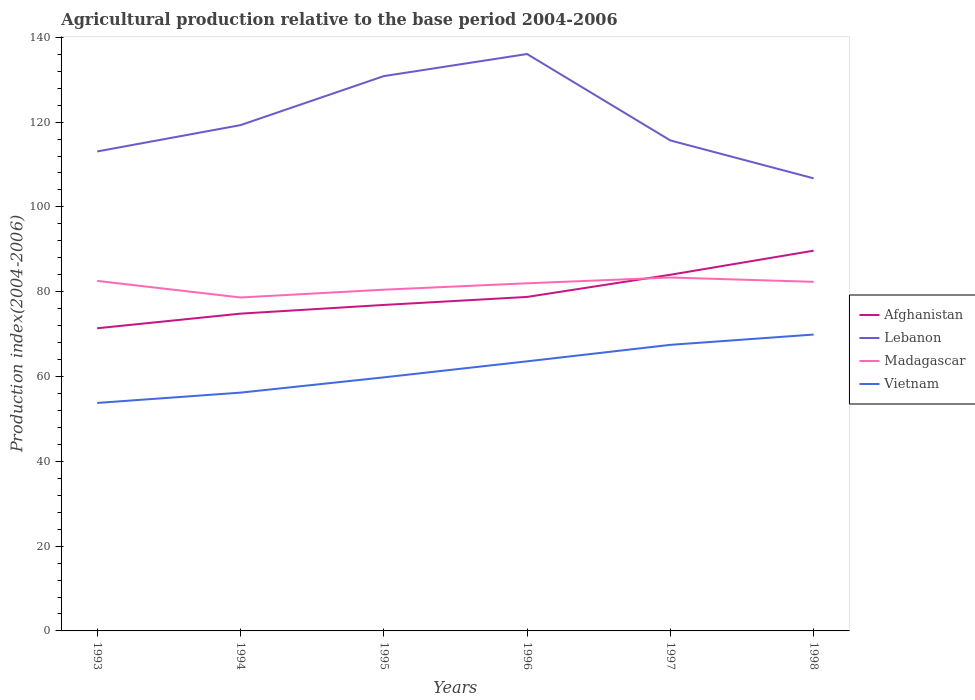How many different coloured lines are there?
Provide a succinct answer. 4. Is the number of lines equal to the number of legend labels?
Give a very brief answer. Yes. Across all years, what is the maximum agricultural production index in Afghanistan?
Provide a short and direct response. 71.38. What is the total agricultural production index in Madagascar in the graph?
Provide a short and direct response. -0.34. What is the difference between the highest and the second highest agricultural production index in Vietnam?
Provide a succinct answer. 16.13. What is the difference between the highest and the lowest agricultural production index in Lebanon?
Provide a succinct answer. 2. Is the agricultural production index in Afghanistan strictly greater than the agricultural production index in Vietnam over the years?
Your response must be concise. No. How many lines are there?
Make the answer very short. 4. Are the values on the major ticks of Y-axis written in scientific E-notation?
Provide a short and direct response. No. How are the legend labels stacked?
Provide a short and direct response. Vertical. What is the title of the graph?
Offer a terse response. Agricultural production relative to the base period 2004-2006. What is the label or title of the Y-axis?
Your response must be concise. Production index(2004-2006). What is the Production index(2004-2006) of Afghanistan in 1993?
Ensure brevity in your answer.  71.38. What is the Production index(2004-2006) in Lebanon in 1993?
Keep it short and to the point. 113.08. What is the Production index(2004-2006) of Madagascar in 1993?
Keep it short and to the point. 82.55. What is the Production index(2004-2006) in Vietnam in 1993?
Offer a terse response. 53.77. What is the Production index(2004-2006) of Afghanistan in 1994?
Make the answer very short. 74.83. What is the Production index(2004-2006) in Lebanon in 1994?
Ensure brevity in your answer.  119.29. What is the Production index(2004-2006) of Madagascar in 1994?
Your response must be concise. 78.64. What is the Production index(2004-2006) in Vietnam in 1994?
Ensure brevity in your answer.  56.2. What is the Production index(2004-2006) of Afghanistan in 1995?
Your response must be concise. 76.88. What is the Production index(2004-2006) in Lebanon in 1995?
Provide a short and direct response. 130.85. What is the Production index(2004-2006) in Madagascar in 1995?
Give a very brief answer. 80.48. What is the Production index(2004-2006) of Vietnam in 1995?
Keep it short and to the point. 59.8. What is the Production index(2004-2006) of Afghanistan in 1996?
Keep it short and to the point. 78.77. What is the Production index(2004-2006) in Lebanon in 1996?
Offer a very short reply. 136.06. What is the Production index(2004-2006) of Madagascar in 1996?
Make the answer very short. 81.99. What is the Production index(2004-2006) of Vietnam in 1996?
Offer a terse response. 63.58. What is the Production index(2004-2006) of Afghanistan in 1997?
Keep it short and to the point. 84. What is the Production index(2004-2006) in Lebanon in 1997?
Make the answer very short. 115.68. What is the Production index(2004-2006) in Madagascar in 1997?
Your response must be concise. 83.35. What is the Production index(2004-2006) of Vietnam in 1997?
Offer a very short reply. 67.47. What is the Production index(2004-2006) of Afghanistan in 1998?
Ensure brevity in your answer.  89.68. What is the Production index(2004-2006) in Lebanon in 1998?
Your response must be concise. 106.74. What is the Production index(2004-2006) in Madagascar in 1998?
Provide a succinct answer. 82.33. What is the Production index(2004-2006) in Vietnam in 1998?
Keep it short and to the point. 69.9. Across all years, what is the maximum Production index(2004-2006) of Afghanistan?
Make the answer very short. 89.68. Across all years, what is the maximum Production index(2004-2006) of Lebanon?
Offer a very short reply. 136.06. Across all years, what is the maximum Production index(2004-2006) of Madagascar?
Provide a succinct answer. 83.35. Across all years, what is the maximum Production index(2004-2006) of Vietnam?
Provide a succinct answer. 69.9. Across all years, what is the minimum Production index(2004-2006) of Afghanistan?
Keep it short and to the point. 71.38. Across all years, what is the minimum Production index(2004-2006) in Lebanon?
Provide a succinct answer. 106.74. Across all years, what is the minimum Production index(2004-2006) in Madagascar?
Offer a very short reply. 78.64. Across all years, what is the minimum Production index(2004-2006) of Vietnam?
Give a very brief answer. 53.77. What is the total Production index(2004-2006) in Afghanistan in the graph?
Your answer should be very brief. 475.54. What is the total Production index(2004-2006) in Lebanon in the graph?
Provide a succinct answer. 721.7. What is the total Production index(2004-2006) in Madagascar in the graph?
Keep it short and to the point. 489.34. What is the total Production index(2004-2006) in Vietnam in the graph?
Offer a terse response. 370.72. What is the difference between the Production index(2004-2006) in Afghanistan in 1993 and that in 1994?
Provide a succinct answer. -3.45. What is the difference between the Production index(2004-2006) in Lebanon in 1993 and that in 1994?
Ensure brevity in your answer.  -6.21. What is the difference between the Production index(2004-2006) of Madagascar in 1993 and that in 1994?
Make the answer very short. 3.91. What is the difference between the Production index(2004-2006) of Vietnam in 1993 and that in 1994?
Your answer should be compact. -2.43. What is the difference between the Production index(2004-2006) of Lebanon in 1993 and that in 1995?
Your answer should be very brief. -17.77. What is the difference between the Production index(2004-2006) of Madagascar in 1993 and that in 1995?
Offer a very short reply. 2.07. What is the difference between the Production index(2004-2006) in Vietnam in 1993 and that in 1995?
Provide a short and direct response. -6.03. What is the difference between the Production index(2004-2006) in Afghanistan in 1993 and that in 1996?
Your answer should be compact. -7.39. What is the difference between the Production index(2004-2006) in Lebanon in 1993 and that in 1996?
Provide a succinct answer. -22.98. What is the difference between the Production index(2004-2006) in Madagascar in 1993 and that in 1996?
Provide a short and direct response. 0.56. What is the difference between the Production index(2004-2006) of Vietnam in 1993 and that in 1996?
Ensure brevity in your answer.  -9.81. What is the difference between the Production index(2004-2006) of Afghanistan in 1993 and that in 1997?
Your answer should be compact. -12.62. What is the difference between the Production index(2004-2006) of Lebanon in 1993 and that in 1997?
Provide a short and direct response. -2.6. What is the difference between the Production index(2004-2006) in Madagascar in 1993 and that in 1997?
Your response must be concise. -0.8. What is the difference between the Production index(2004-2006) in Vietnam in 1993 and that in 1997?
Make the answer very short. -13.7. What is the difference between the Production index(2004-2006) of Afghanistan in 1993 and that in 1998?
Your answer should be very brief. -18.3. What is the difference between the Production index(2004-2006) of Lebanon in 1993 and that in 1998?
Provide a succinct answer. 6.34. What is the difference between the Production index(2004-2006) in Madagascar in 1993 and that in 1998?
Your answer should be very brief. 0.22. What is the difference between the Production index(2004-2006) in Vietnam in 1993 and that in 1998?
Provide a succinct answer. -16.13. What is the difference between the Production index(2004-2006) in Afghanistan in 1994 and that in 1995?
Offer a very short reply. -2.05. What is the difference between the Production index(2004-2006) in Lebanon in 1994 and that in 1995?
Your answer should be compact. -11.56. What is the difference between the Production index(2004-2006) in Madagascar in 1994 and that in 1995?
Your answer should be very brief. -1.84. What is the difference between the Production index(2004-2006) in Vietnam in 1994 and that in 1995?
Give a very brief answer. -3.6. What is the difference between the Production index(2004-2006) in Afghanistan in 1994 and that in 1996?
Your answer should be very brief. -3.94. What is the difference between the Production index(2004-2006) in Lebanon in 1994 and that in 1996?
Offer a terse response. -16.77. What is the difference between the Production index(2004-2006) in Madagascar in 1994 and that in 1996?
Keep it short and to the point. -3.35. What is the difference between the Production index(2004-2006) of Vietnam in 1994 and that in 1996?
Offer a very short reply. -7.38. What is the difference between the Production index(2004-2006) of Afghanistan in 1994 and that in 1997?
Provide a succinct answer. -9.17. What is the difference between the Production index(2004-2006) of Lebanon in 1994 and that in 1997?
Provide a short and direct response. 3.61. What is the difference between the Production index(2004-2006) of Madagascar in 1994 and that in 1997?
Offer a very short reply. -4.71. What is the difference between the Production index(2004-2006) of Vietnam in 1994 and that in 1997?
Your response must be concise. -11.27. What is the difference between the Production index(2004-2006) in Afghanistan in 1994 and that in 1998?
Offer a terse response. -14.85. What is the difference between the Production index(2004-2006) of Lebanon in 1994 and that in 1998?
Ensure brevity in your answer.  12.55. What is the difference between the Production index(2004-2006) in Madagascar in 1994 and that in 1998?
Keep it short and to the point. -3.69. What is the difference between the Production index(2004-2006) of Vietnam in 1994 and that in 1998?
Offer a terse response. -13.7. What is the difference between the Production index(2004-2006) of Afghanistan in 1995 and that in 1996?
Provide a succinct answer. -1.89. What is the difference between the Production index(2004-2006) in Lebanon in 1995 and that in 1996?
Offer a terse response. -5.21. What is the difference between the Production index(2004-2006) in Madagascar in 1995 and that in 1996?
Keep it short and to the point. -1.51. What is the difference between the Production index(2004-2006) of Vietnam in 1995 and that in 1996?
Make the answer very short. -3.78. What is the difference between the Production index(2004-2006) of Afghanistan in 1995 and that in 1997?
Ensure brevity in your answer.  -7.12. What is the difference between the Production index(2004-2006) of Lebanon in 1995 and that in 1997?
Offer a very short reply. 15.17. What is the difference between the Production index(2004-2006) of Madagascar in 1995 and that in 1997?
Provide a short and direct response. -2.87. What is the difference between the Production index(2004-2006) in Vietnam in 1995 and that in 1997?
Your response must be concise. -7.67. What is the difference between the Production index(2004-2006) in Lebanon in 1995 and that in 1998?
Offer a very short reply. 24.11. What is the difference between the Production index(2004-2006) in Madagascar in 1995 and that in 1998?
Offer a terse response. -1.85. What is the difference between the Production index(2004-2006) of Afghanistan in 1996 and that in 1997?
Keep it short and to the point. -5.23. What is the difference between the Production index(2004-2006) in Lebanon in 1996 and that in 1997?
Keep it short and to the point. 20.38. What is the difference between the Production index(2004-2006) in Madagascar in 1996 and that in 1997?
Ensure brevity in your answer.  -1.36. What is the difference between the Production index(2004-2006) of Vietnam in 1996 and that in 1997?
Give a very brief answer. -3.89. What is the difference between the Production index(2004-2006) of Afghanistan in 1996 and that in 1998?
Provide a succinct answer. -10.91. What is the difference between the Production index(2004-2006) in Lebanon in 1996 and that in 1998?
Offer a terse response. 29.32. What is the difference between the Production index(2004-2006) of Madagascar in 1996 and that in 1998?
Make the answer very short. -0.34. What is the difference between the Production index(2004-2006) of Vietnam in 1996 and that in 1998?
Offer a terse response. -6.32. What is the difference between the Production index(2004-2006) in Afghanistan in 1997 and that in 1998?
Make the answer very short. -5.68. What is the difference between the Production index(2004-2006) in Lebanon in 1997 and that in 1998?
Your answer should be compact. 8.94. What is the difference between the Production index(2004-2006) in Vietnam in 1997 and that in 1998?
Your response must be concise. -2.43. What is the difference between the Production index(2004-2006) in Afghanistan in 1993 and the Production index(2004-2006) in Lebanon in 1994?
Keep it short and to the point. -47.91. What is the difference between the Production index(2004-2006) in Afghanistan in 1993 and the Production index(2004-2006) in Madagascar in 1994?
Offer a very short reply. -7.26. What is the difference between the Production index(2004-2006) in Afghanistan in 1993 and the Production index(2004-2006) in Vietnam in 1994?
Provide a short and direct response. 15.18. What is the difference between the Production index(2004-2006) in Lebanon in 1993 and the Production index(2004-2006) in Madagascar in 1994?
Your answer should be very brief. 34.44. What is the difference between the Production index(2004-2006) in Lebanon in 1993 and the Production index(2004-2006) in Vietnam in 1994?
Offer a very short reply. 56.88. What is the difference between the Production index(2004-2006) of Madagascar in 1993 and the Production index(2004-2006) of Vietnam in 1994?
Offer a terse response. 26.35. What is the difference between the Production index(2004-2006) of Afghanistan in 1993 and the Production index(2004-2006) of Lebanon in 1995?
Your answer should be very brief. -59.47. What is the difference between the Production index(2004-2006) in Afghanistan in 1993 and the Production index(2004-2006) in Vietnam in 1995?
Provide a short and direct response. 11.58. What is the difference between the Production index(2004-2006) of Lebanon in 1993 and the Production index(2004-2006) of Madagascar in 1995?
Offer a very short reply. 32.6. What is the difference between the Production index(2004-2006) of Lebanon in 1993 and the Production index(2004-2006) of Vietnam in 1995?
Provide a short and direct response. 53.28. What is the difference between the Production index(2004-2006) of Madagascar in 1993 and the Production index(2004-2006) of Vietnam in 1995?
Provide a short and direct response. 22.75. What is the difference between the Production index(2004-2006) of Afghanistan in 1993 and the Production index(2004-2006) of Lebanon in 1996?
Offer a terse response. -64.68. What is the difference between the Production index(2004-2006) in Afghanistan in 1993 and the Production index(2004-2006) in Madagascar in 1996?
Your answer should be compact. -10.61. What is the difference between the Production index(2004-2006) in Lebanon in 1993 and the Production index(2004-2006) in Madagascar in 1996?
Give a very brief answer. 31.09. What is the difference between the Production index(2004-2006) of Lebanon in 1993 and the Production index(2004-2006) of Vietnam in 1996?
Make the answer very short. 49.5. What is the difference between the Production index(2004-2006) of Madagascar in 1993 and the Production index(2004-2006) of Vietnam in 1996?
Offer a terse response. 18.97. What is the difference between the Production index(2004-2006) in Afghanistan in 1993 and the Production index(2004-2006) in Lebanon in 1997?
Make the answer very short. -44.3. What is the difference between the Production index(2004-2006) in Afghanistan in 1993 and the Production index(2004-2006) in Madagascar in 1997?
Make the answer very short. -11.97. What is the difference between the Production index(2004-2006) of Afghanistan in 1993 and the Production index(2004-2006) of Vietnam in 1997?
Your response must be concise. 3.91. What is the difference between the Production index(2004-2006) in Lebanon in 1993 and the Production index(2004-2006) in Madagascar in 1997?
Make the answer very short. 29.73. What is the difference between the Production index(2004-2006) in Lebanon in 1993 and the Production index(2004-2006) in Vietnam in 1997?
Your response must be concise. 45.61. What is the difference between the Production index(2004-2006) in Madagascar in 1993 and the Production index(2004-2006) in Vietnam in 1997?
Provide a short and direct response. 15.08. What is the difference between the Production index(2004-2006) in Afghanistan in 1993 and the Production index(2004-2006) in Lebanon in 1998?
Ensure brevity in your answer.  -35.36. What is the difference between the Production index(2004-2006) in Afghanistan in 1993 and the Production index(2004-2006) in Madagascar in 1998?
Offer a terse response. -10.95. What is the difference between the Production index(2004-2006) of Afghanistan in 1993 and the Production index(2004-2006) of Vietnam in 1998?
Provide a succinct answer. 1.48. What is the difference between the Production index(2004-2006) in Lebanon in 1993 and the Production index(2004-2006) in Madagascar in 1998?
Give a very brief answer. 30.75. What is the difference between the Production index(2004-2006) of Lebanon in 1993 and the Production index(2004-2006) of Vietnam in 1998?
Ensure brevity in your answer.  43.18. What is the difference between the Production index(2004-2006) in Madagascar in 1993 and the Production index(2004-2006) in Vietnam in 1998?
Your response must be concise. 12.65. What is the difference between the Production index(2004-2006) of Afghanistan in 1994 and the Production index(2004-2006) of Lebanon in 1995?
Give a very brief answer. -56.02. What is the difference between the Production index(2004-2006) of Afghanistan in 1994 and the Production index(2004-2006) of Madagascar in 1995?
Offer a terse response. -5.65. What is the difference between the Production index(2004-2006) in Afghanistan in 1994 and the Production index(2004-2006) in Vietnam in 1995?
Keep it short and to the point. 15.03. What is the difference between the Production index(2004-2006) of Lebanon in 1994 and the Production index(2004-2006) of Madagascar in 1995?
Provide a succinct answer. 38.81. What is the difference between the Production index(2004-2006) in Lebanon in 1994 and the Production index(2004-2006) in Vietnam in 1995?
Provide a succinct answer. 59.49. What is the difference between the Production index(2004-2006) of Madagascar in 1994 and the Production index(2004-2006) of Vietnam in 1995?
Offer a very short reply. 18.84. What is the difference between the Production index(2004-2006) in Afghanistan in 1994 and the Production index(2004-2006) in Lebanon in 1996?
Provide a succinct answer. -61.23. What is the difference between the Production index(2004-2006) of Afghanistan in 1994 and the Production index(2004-2006) of Madagascar in 1996?
Provide a succinct answer. -7.16. What is the difference between the Production index(2004-2006) of Afghanistan in 1994 and the Production index(2004-2006) of Vietnam in 1996?
Ensure brevity in your answer.  11.25. What is the difference between the Production index(2004-2006) of Lebanon in 1994 and the Production index(2004-2006) of Madagascar in 1996?
Provide a short and direct response. 37.3. What is the difference between the Production index(2004-2006) of Lebanon in 1994 and the Production index(2004-2006) of Vietnam in 1996?
Offer a terse response. 55.71. What is the difference between the Production index(2004-2006) in Madagascar in 1994 and the Production index(2004-2006) in Vietnam in 1996?
Offer a very short reply. 15.06. What is the difference between the Production index(2004-2006) in Afghanistan in 1994 and the Production index(2004-2006) in Lebanon in 1997?
Make the answer very short. -40.85. What is the difference between the Production index(2004-2006) of Afghanistan in 1994 and the Production index(2004-2006) of Madagascar in 1997?
Give a very brief answer. -8.52. What is the difference between the Production index(2004-2006) in Afghanistan in 1994 and the Production index(2004-2006) in Vietnam in 1997?
Provide a short and direct response. 7.36. What is the difference between the Production index(2004-2006) in Lebanon in 1994 and the Production index(2004-2006) in Madagascar in 1997?
Offer a terse response. 35.94. What is the difference between the Production index(2004-2006) in Lebanon in 1994 and the Production index(2004-2006) in Vietnam in 1997?
Give a very brief answer. 51.82. What is the difference between the Production index(2004-2006) in Madagascar in 1994 and the Production index(2004-2006) in Vietnam in 1997?
Offer a very short reply. 11.17. What is the difference between the Production index(2004-2006) in Afghanistan in 1994 and the Production index(2004-2006) in Lebanon in 1998?
Provide a short and direct response. -31.91. What is the difference between the Production index(2004-2006) in Afghanistan in 1994 and the Production index(2004-2006) in Vietnam in 1998?
Offer a terse response. 4.93. What is the difference between the Production index(2004-2006) of Lebanon in 1994 and the Production index(2004-2006) of Madagascar in 1998?
Provide a succinct answer. 36.96. What is the difference between the Production index(2004-2006) of Lebanon in 1994 and the Production index(2004-2006) of Vietnam in 1998?
Offer a very short reply. 49.39. What is the difference between the Production index(2004-2006) of Madagascar in 1994 and the Production index(2004-2006) of Vietnam in 1998?
Offer a very short reply. 8.74. What is the difference between the Production index(2004-2006) of Afghanistan in 1995 and the Production index(2004-2006) of Lebanon in 1996?
Give a very brief answer. -59.18. What is the difference between the Production index(2004-2006) in Afghanistan in 1995 and the Production index(2004-2006) in Madagascar in 1996?
Give a very brief answer. -5.11. What is the difference between the Production index(2004-2006) in Lebanon in 1995 and the Production index(2004-2006) in Madagascar in 1996?
Make the answer very short. 48.86. What is the difference between the Production index(2004-2006) in Lebanon in 1995 and the Production index(2004-2006) in Vietnam in 1996?
Your answer should be compact. 67.27. What is the difference between the Production index(2004-2006) of Madagascar in 1995 and the Production index(2004-2006) of Vietnam in 1996?
Ensure brevity in your answer.  16.9. What is the difference between the Production index(2004-2006) of Afghanistan in 1995 and the Production index(2004-2006) of Lebanon in 1997?
Offer a terse response. -38.8. What is the difference between the Production index(2004-2006) of Afghanistan in 1995 and the Production index(2004-2006) of Madagascar in 1997?
Make the answer very short. -6.47. What is the difference between the Production index(2004-2006) in Afghanistan in 1995 and the Production index(2004-2006) in Vietnam in 1997?
Provide a short and direct response. 9.41. What is the difference between the Production index(2004-2006) in Lebanon in 1995 and the Production index(2004-2006) in Madagascar in 1997?
Give a very brief answer. 47.5. What is the difference between the Production index(2004-2006) in Lebanon in 1995 and the Production index(2004-2006) in Vietnam in 1997?
Offer a terse response. 63.38. What is the difference between the Production index(2004-2006) of Madagascar in 1995 and the Production index(2004-2006) of Vietnam in 1997?
Give a very brief answer. 13.01. What is the difference between the Production index(2004-2006) in Afghanistan in 1995 and the Production index(2004-2006) in Lebanon in 1998?
Provide a short and direct response. -29.86. What is the difference between the Production index(2004-2006) of Afghanistan in 1995 and the Production index(2004-2006) of Madagascar in 1998?
Give a very brief answer. -5.45. What is the difference between the Production index(2004-2006) of Afghanistan in 1995 and the Production index(2004-2006) of Vietnam in 1998?
Give a very brief answer. 6.98. What is the difference between the Production index(2004-2006) of Lebanon in 1995 and the Production index(2004-2006) of Madagascar in 1998?
Offer a terse response. 48.52. What is the difference between the Production index(2004-2006) of Lebanon in 1995 and the Production index(2004-2006) of Vietnam in 1998?
Your response must be concise. 60.95. What is the difference between the Production index(2004-2006) of Madagascar in 1995 and the Production index(2004-2006) of Vietnam in 1998?
Your response must be concise. 10.58. What is the difference between the Production index(2004-2006) in Afghanistan in 1996 and the Production index(2004-2006) in Lebanon in 1997?
Offer a terse response. -36.91. What is the difference between the Production index(2004-2006) in Afghanistan in 1996 and the Production index(2004-2006) in Madagascar in 1997?
Your response must be concise. -4.58. What is the difference between the Production index(2004-2006) in Afghanistan in 1996 and the Production index(2004-2006) in Vietnam in 1997?
Give a very brief answer. 11.3. What is the difference between the Production index(2004-2006) of Lebanon in 1996 and the Production index(2004-2006) of Madagascar in 1997?
Keep it short and to the point. 52.71. What is the difference between the Production index(2004-2006) of Lebanon in 1996 and the Production index(2004-2006) of Vietnam in 1997?
Provide a short and direct response. 68.59. What is the difference between the Production index(2004-2006) in Madagascar in 1996 and the Production index(2004-2006) in Vietnam in 1997?
Provide a succinct answer. 14.52. What is the difference between the Production index(2004-2006) in Afghanistan in 1996 and the Production index(2004-2006) in Lebanon in 1998?
Ensure brevity in your answer.  -27.97. What is the difference between the Production index(2004-2006) of Afghanistan in 1996 and the Production index(2004-2006) of Madagascar in 1998?
Give a very brief answer. -3.56. What is the difference between the Production index(2004-2006) in Afghanistan in 1996 and the Production index(2004-2006) in Vietnam in 1998?
Make the answer very short. 8.87. What is the difference between the Production index(2004-2006) in Lebanon in 1996 and the Production index(2004-2006) in Madagascar in 1998?
Your response must be concise. 53.73. What is the difference between the Production index(2004-2006) in Lebanon in 1996 and the Production index(2004-2006) in Vietnam in 1998?
Provide a succinct answer. 66.16. What is the difference between the Production index(2004-2006) of Madagascar in 1996 and the Production index(2004-2006) of Vietnam in 1998?
Ensure brevity in your answer.  12.09. What is the difference between the Production index(2004-2006) of Afghanistan in 1997 and the Production index(2004-2006) of Lebanon in 1998?
Your response must be concise. -22.74. What is the difference between the Production index(2004-2006) in Afghanistan in 1997 and the Production index(2004-2006) in Madagascar in 1998?
Offer a very short reply. 1.67. What is the difference between the Production index(2004-2006) of Lebanon in 1997 and the Production index(2004-2006) of Madagascar in 1998?
Make the answer very short. 33.35. What is the difference between the Production index(2004-2006) in Lebanon in 1997 and the Production index(2004-2006) in Vietnam in 1998?
Your answer should be compact. 45.78. What is the difference between the Production index(2004-2006) of Madagascar in 1997 and the Production index(2004-2006) of Vietnam in 1998?
Your answer should be compact. 13.45. What is the average Production index(2004-2006) in Afghanistan per year?
Make the answer very short. 79.26. What is the average Production index(2004-2006) in Lebanon per year?
Provide a short and direct response. 120.28. What is the average Production index(2004-2006) of Madagascar per year?
Provide a succinct answer. 81.56. What is the average Production index(2004-2006) in Vietnam per year?
Ensure brevity in your answer.  61.79. In the year 1993, what is the difference between the Production index(2004-2006) of Afghanistan and Production index(2004-2006) of Lebanon?
Provide a short and direct response. -41.7. In the year 1993, what is the difference between the Production index(2004-2006) in Afghanistan and Production index(2004-2006) in Madagascar?
Your response must be concise. -11.17. In the year 1993, what is the difference between the Production index(2004-2006) in Afghanistan and Production index(2004-2006) in Vietnam?
Offer a terse response. 17.61. In the year 1993, what is the difference between the Production index(2004-2006) of Lebanon and Production index(2004-2006) of Madagascar?
Your answer should be compact. 30.53. In the year 1993, what is the difference between the Production index(2004-2006) of Lebanon and Production index(2004-2006) of Vietnam?
Provide a short and direct response. 59.31. In the year 1993, what is the difference between the Production index(2004-2006) of Madagascar and Production index(2004-2006) of Vietnam?
Provide a short and direct response. 28.78. In the year 1994, what is the difference between the Production index(2004-2006) of Afghanistan and Production index(2004-2006) of Lebanon?
Give a very brief answer. -44.46. In the year 1994, what is the difference between the Production index(2004-2006) of Afghanistan and Production index(2004-2006) of Madagascar?
Provide a succinct answer. -3.81. In the year 1994, what is the difference between the Production index(2004-2006) in Afghanistan and Production index(2004-2006) in Vietnam?
Your response must be concise. 18.63. In the year 1994, what is the difference between the Production index(2004-2006) of Lebanon and Production index(2004-2006) of Madagascar?
Provide a succinct answer. 40.65. In the year 1994, what is the difference between the Production index(2004-2006) of Lebanon and Production index(2004-2006) of Vietnam?
Provide a succinct answer. 63.09. In the year 1994, what is the difference between the Production index(2004-2006) in Madagascar and Production index(2004-2006) in Vietnam?
Ensure brevity in your answer.  22.44. In the year 1995, what is the difference between the Production index(2004-2006) of Afghanistan and Production index(2004-2006) of Lebanon?
Your response must be concise. -53.97. In the year 1995, what is the difference between the Production index(2004-2006) of Afghanistan and Production index(2004-2006) of Madagascar?
Provide a succinct answer. -3.6. In the year 1995, what is the difference between the Production index(2004-2006) in Afghanistan and Production index(2004-2006) in Vietnam?
Offer a very short reply. 17.08. In the year 1995, what is the difference between the Production index(2004-2006) in Lebanon and Production index(2004-2006) in Madagascar?
Make the answer very short. 50.37. In the year 1995, what is the difference between the Production index(2004-2006) in Lebanon and Production index(2004-2006) in Vietnam?
Give a very brief answer. 71.05. In the year 1995, what is the difference between the Production index(2004-2006) of Madagascar and Production index(2004-2006) of Vietnam?
Keep it short and to the point. 20.68. In the year 1996, what is the difference between the Production index(2004-2006) in Afghanistan and Production index(2004-2006) in Lebanon?
Offer a very short reply. -57.29. In the year 1996, what is the difference between the Production index(2004-2006) of Afghanistan and Production index(2004-2006) of Madagascar?
Offer a very short reply. -3.22. In the year 1996, what is the difference between the Production index(2004-2006) of Afghanistan and Production index(2004-2006) of Vietnam?
Offer a terse response. 15.19. In the year 1996, what is the difference between the Production index(2004-2006) in Lebanon and Production index(2004-2006) in Madagascar?
Offer a very short reply. 54.07. In the year 1996, what is the difference between the Production index(2004-2006) of Lebanon and Production index(2004-2006) of Vietnam?
Provide a short and direct response. 72.48. In the year 1996, what is the difference between the Production index(2004-2006) of Madagascar and Production index(2004-2006) of Vietnam?
Give a very brief answer. 18.41. In the year 1997, what is the difference between the Production index(2004-2006) in Afghanistan and Production index(2004-2006) in Lebanon?
Ensure brevity in your answer.  -31.68. In the year 1997, what is the difference between the Production index(2004-2006) in Afghanistan and Production index(2004-2006) in Madagascar?
Provide a succinct answer. 0.65. In the year 1997, what is the difference between the Production index(2004-2006) of Afghanistan and Production index(2004-2006) of Vietnam?
Your response must be concise. 16.53. In the year 1997, what is the difference between the Production index(2004-2006) of Lebanon and Production index(2004-2006) of Madagascar?
Your answer should be very brief. 32.33. In the year 1997, what is the difference between the Production index(2004-2006) in Lebanon and Production index(2004-2006) in Vietnam?
Your response must be concise. 48.21. In the year 1997, what is the difference between the Production index(2004-2006) in Madagascar and Production index(2004-2006) in Vietnam?
Provide a succinct answer. 15.88. In the year 1998, what is the difference between the Production index(2004-2006) in Afghanistan and Production index(2004-2006) in Lebanon?
Your answer should be compact. -17.06. In the year 1998, what is the difference between the Production index(2004-2006) of Afghanistan and Production index(2004-2006) of Madagascar?
Offer a terse response. 7.35. In the year 1998, what is the difference between the Production index(2004-2006) in Afghanistan and Production index(2004-2006) in Vietnam?
Ensure brevity in your answer.  19.78. In the year 1998, what is the difference between the Production index(2004-2006) of Lebanon and Production index(2004-2006) of Madagascar?
Your answer should be compact. 24.41. In the year 1998, what is the difference between the Production index(2004-2006) of Lebanon and Production index(2004-2006) of Vietnam?
Your answer should be very brief. 36.84. In the year 1998, what is the difference between the Production index(2004-2006) of Madagascar and Production index(2004-2006) of Vietnam?
Provide a succinct answer. 12.43. What is the ratio of the Production index(2004-2006) of Afghanistan in 1993 to that in 1994?
Ensure brevity in your answer.  0.95. What is the ratio of the Production index(2004-2006) of Lebanon in 1993 to that in 1994?
Offer a terse response. 0.95. What is the ratio of the Production index(2004-2006) of Madagascar in 1993 to that in 1994?
Your response must be concise. 1.05. What is the ratio of the Production index(2004-2006) of Vietnam in 1993 to that in 1994?
Offer a very short reply. 0.96. What is the ratio of the Production index(2004-2006) of Afghanistan in 1993 to that in 1995?
Offer a very short reply. 0.93. What is the ratio of the Production index(2004-2006) in Lebanon in 1993 to that in 1995?
Your answer should be compact. 0.86. What is the ratio of the Production index(2004-2006) of Madagascar in 1993 to that in 1995?
Your answer should be compact. 1.03. What is the ratio of the Production index(2004-2006) of Vietnam in 1993 to that in 1995?
Offer a terse response. 0.9. What is the ratio of the Production index(2004-2006) in Afghanistan in 1993 to that in 1996?
Your answer should be very brief. 0.91. What is the ratio of the Production index(2004-2006) of Lebanon in 1993 to that in 1996?
Keep it short and to the point. 0.83. What is the ratio of the Production index(2004-2006) of Madagascar in 1993 to that in 1996?
Your answer should be very brief. 1.01. What is the ratio of the Production index(2004-2006) of Vietnam in 1993 to that in 1996?
Ensure brevity in your answer.  0.85. What is the ratio of the Production index(2004-2006) in Afghanistan in 1993 to that in 1997?
Provide a short and direct response. 0.85. What is the ratio of the Production index(2004-2006) of Lebanon in 1993 to that in 1997?
Keep it short and to the point. 0.98. What is the ratio of the Production index(2004-2006) in Vietnam in 1993 to that in 1997?
Offer a very short reply. 0.8. What is the ratio of the Production index(2004-2006) in Afghanistan in 1993 to that in 1998?
Provide a short and direct response. 0.8. What is the ratio of the Production index(2004-2006) of Lebanon in 1993 to that in 1998?
Provide a succinct answer. 1.06. What is the ratio of the Production index(2004-2006) in Madagascar in 1993 to that in 1998?
Provide a succinct answer. 1. What is the ratio of the Production index(2004-2006) of Vietnam in 1993 to that in 1998?
Make the answer very short. 0.77. What is the ratio of the Production index(2004-2006) in Afghanistan in 1994 to that in 1995?
Your answer should be very brief. 0.97. What is the ratio of the Production index(2004-2006) of Lebanon in 1994 to that in 1995?
Provide a succinct answer. 0.91. What is the ratio of the Production index(2004-2006) in Madagascar in 1994 to that in 1995?
Your response must be concise. 0.98. What is the ratio of the Production index(2004-2006) of Vietnam in 1994 to that in 1995?
Give a very brief answer. 0.94. What is the ratio of the Production index(2004-2006) of Lebanon in 1994 to that in 1996?
Your response must be concise. 0.88. What is the ratio of the Production index(2004-2006) of Madagascar in 1994 to that in 1996?
Your response must be concise. 0.96. What is the ratio of the Production index(2004-2006) of Vietnam in 1994 to that in 1996?
Provide a succinct answer. 0.88. What is the ratio of the Production index(2004-2006) in Afghanistan in 1994 to that in 1997?
Make the answer very short. 0.89. What is the ratio of the Production index(2004-2006) of Lebanon in 1994 to that in 1997?
Your response must be concise. 1.03. What is the ratio of the Production index(2004-2006) in Madagascar in 1994 to that in 1997?
Offer a very short reply. 0.94. What is the ratio of the Production index(2004-2006) in Vietnam in 1994 to that in 1997?
Provide a succinct answer. 0.83. What is the ratio of the Production index(2004-2006) in Afghanistan in 1994 to that in 1998?
Give a very brief answer. 0.83. What is the ratio of the Production index(2004-2006) of Lebanon in 1994 to that in 1998?
Keep it short and to the point. 1.12. What is the ratio of the Production index(2004-2006) of Madagascar in 1994 to that in 1998?
Your response must be concise. 0.96. What is the ratio of the Production index(2004-2006) of Vietnam in 1994 to that in 1998?
Provide a short and direct response. 0.8. What is the ratio of the Production index(2004-2006) of Afghanistan in 1995 to that in 1996?
Provide a short and direct response. 0.98. What is the ratio of the Production index(2004-2006) in Lebanon in 1995 to that in 1996?
Offer a terse response. 0.96. What is the ratio of the Production index(2004-2006) of Madagascar in 1995 to that in 1996?
Ensure brevity in your answer.  0.98. What is the ratio of the Production index(2004-2006) in Vietnam in 1995 to that in 1996?
Ensure brevity in your answer.  0.94. What is the ratio of the Production index(2004-2006) in Afghanistan in 1995 to that in 1997?
Give a very brief answer. 0.92. What is the ratio of the Production index(2004-2006) in Lebanon in 1995 to that in 1997?
Provide a short and direct response. 1.13. What is the ratio of the Production index(2004-2006) in Madagascar in 1995 to that in 1997?
Give a very brief answer. 0.97. What is the ratio of the Production index(2004-2006) in Vietnam in 1995 to that in 1997?
Your response must be concise. 0.89. What is the ratio of the Production index(2004-2006) of Afghanistan in 1995 to that in 1998?
Provide a succinct answer. 0.86. What is the ratio of the Production index(2004-2006) of Lebanon in 1995 to that in 1998?
Your response must be concise. 1.23. What is the ratio of the Production index(2004-2006) of Madagascar in 1995 to that in 1998?
Give a very brief answer. 0.98. What is the ratio of the Production index(2004-2006) of Vietnam in 1995 to that in 1998?
Make the answer very short. 0.86. What is the ratio of the Production index(2004-2006) of Afghanistan in 1996 to that in 1997?
Give a very brief answer. 0.94. What is the ratio of the Production index(2004-2006) of Lebanon in 1996 to that in 1997?
Offer a terse response. 1.18. What is the ratio of the Production index(2004-2006) of Madagascar in 1996 to that in 1997?
Provide a short and direct response. 0.98. What is the ratio of the Production index(2004-2006) of Vietnam in 1996 to that in 1997?
Provide a short and direct response. 0.94. What is the ratio of the Production index(2004-2006) of Afghanistan in 1996 to that in 1998?
Keep it short and to the point. 0.88. What is the ratio of the Production index(2004-2006) of Lebanon in 1996 to that in 1998?
Offer a very short reply. 1.27. What is the ratio of the Production index(2004-2006) in Madagascar in 1996 to that in 1998?
Keep it short and to the point. 1. What is the ratio of the Production index(2004-2006) of Vietnam in 1996 to that in 1998?
Provide a short and direct response. 0.91. What is the ratio of the Production index(2004-2006) in Afghanistan in 1997 to that in 1998?
Provide a succinct answer. 0.94. What is the ratio of the Production index(2004-2006) in Lebanon in 1997 to that in 1998?
Ensure brevity in your answer.  1.08. What is the ratio of the Production index(2004-2006) in Madagascar in 1997 to that in 1998?
Offer a terse response. 1.01. What is the ratio of the Production index(2004-2006) of Vietnam in 1997 to that in 1998?
Keep it short and to the point. 0.97. What is the difference between the highest and the second highest Production index(2004-2006) in Afghanistan?
Offer a terse response. 5.68. What is the difference between the highest and the second highest Production index(2004-2006) in Lebanon?
Make the answer very short. 5.21. What is the difference between the highest and the second highest Production index(2004-2006) in Vietnam?
Your response must be concise. 2.43. What is the difference between the highest and the lowest Production index(2004-2006) of Lebanon?
Offer a very short reply. 29.32. What is the difference between the highest and the lowest Production index(2004-2006) in Madagascar?
Offer a terse response. 4.71. What is the difference between the highest and the lowest Production index(2004-2006) in Vietnam?
Provide a succinct answer. 16.13. 